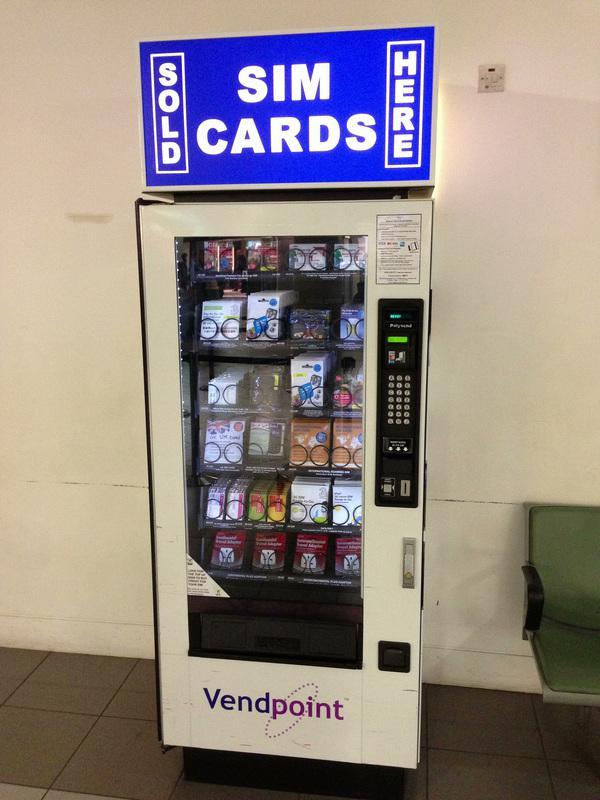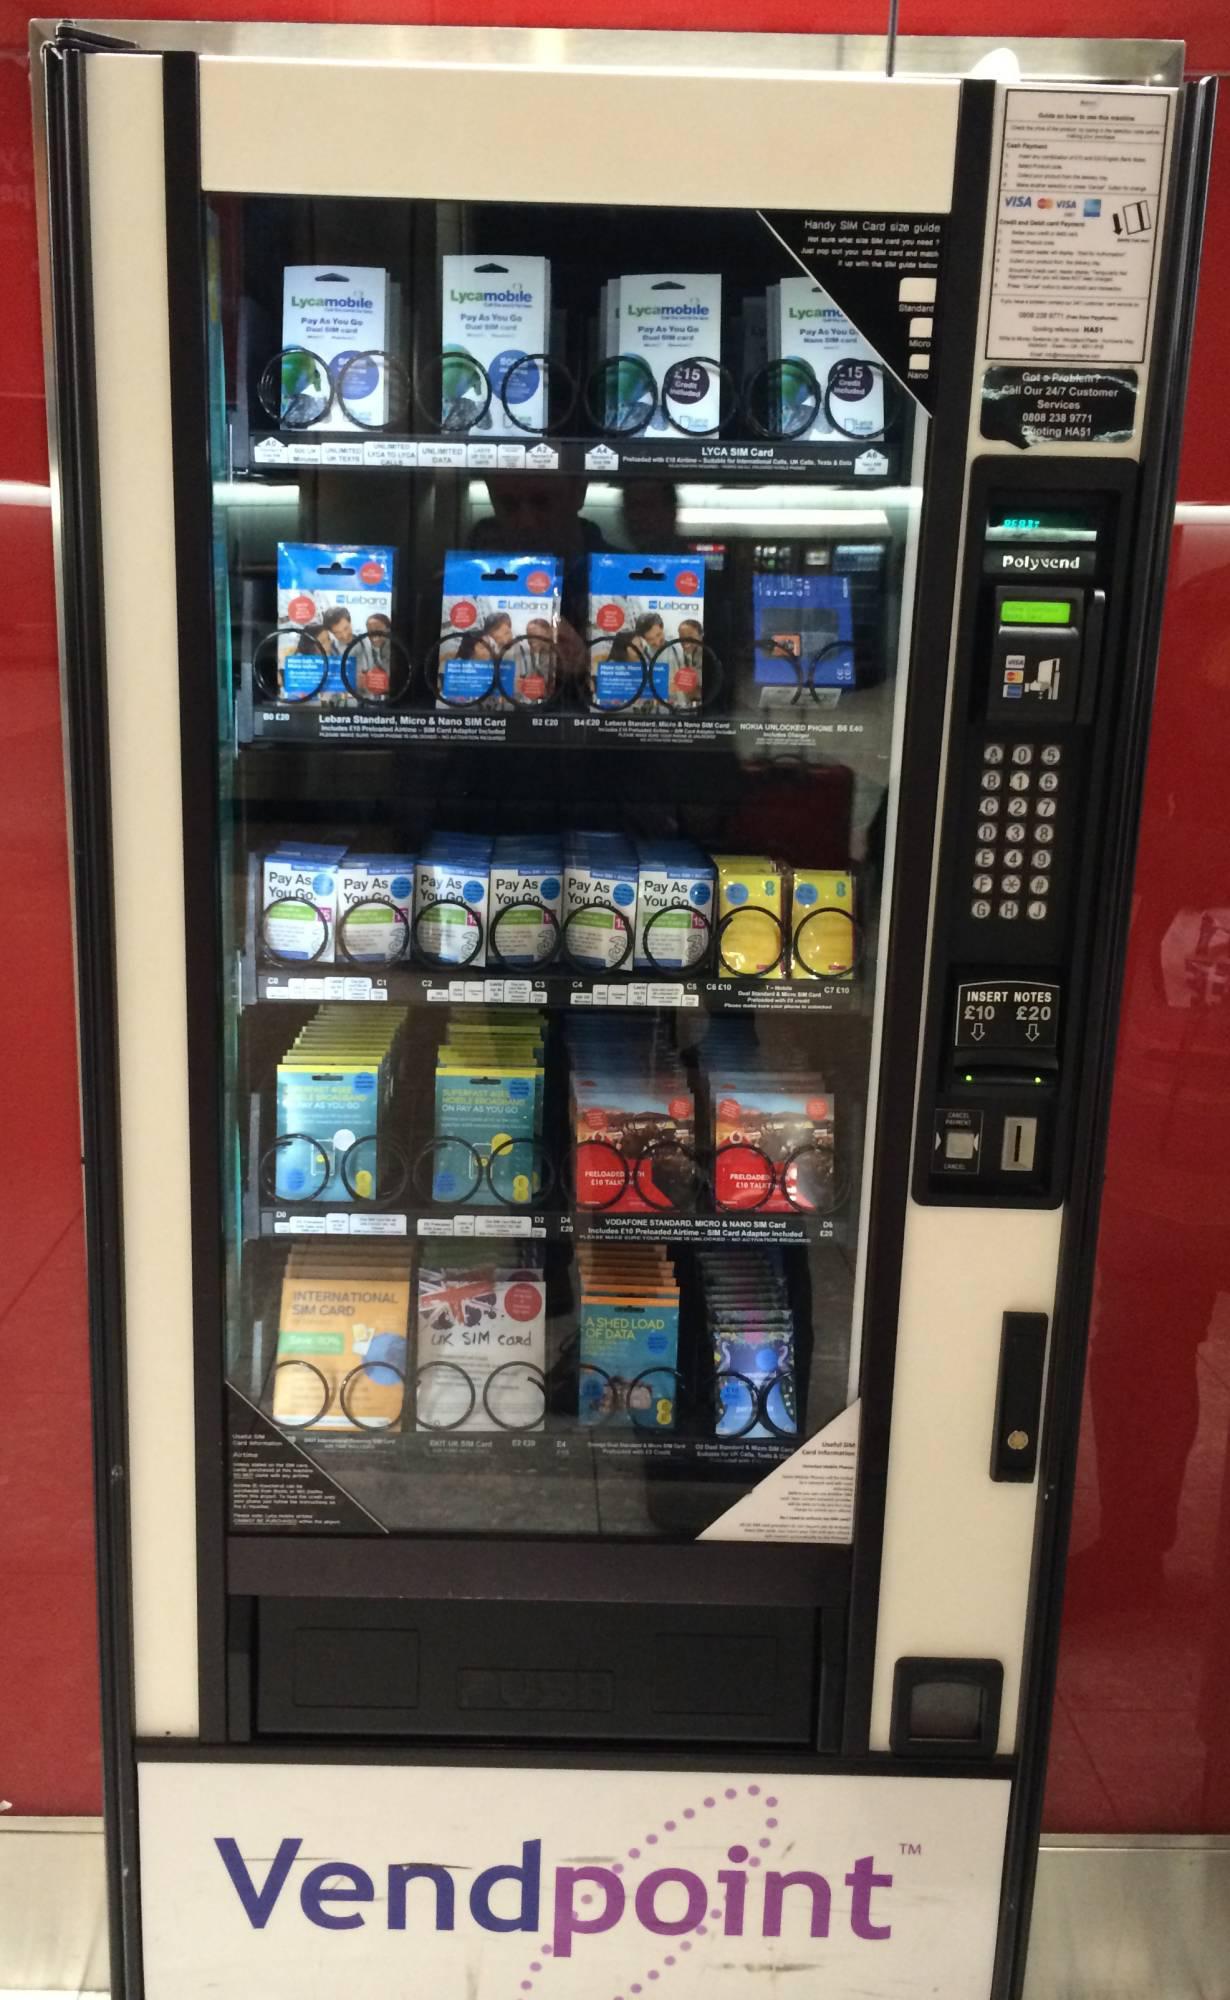The first image is the image on the left, the second image is the image on the right. For the images displayed, is the sentence "You can clearly see that the vending machine on the left is up against a solid wall." factually correct? Answer yes or no. Yes. The first image is the image on the left, the second image is the image on the right. For the images displayed, is the sentence "There is a single Sim card vending  with a large blue sign set against a white wall." factually correct? Answer yes or no. Yes. 